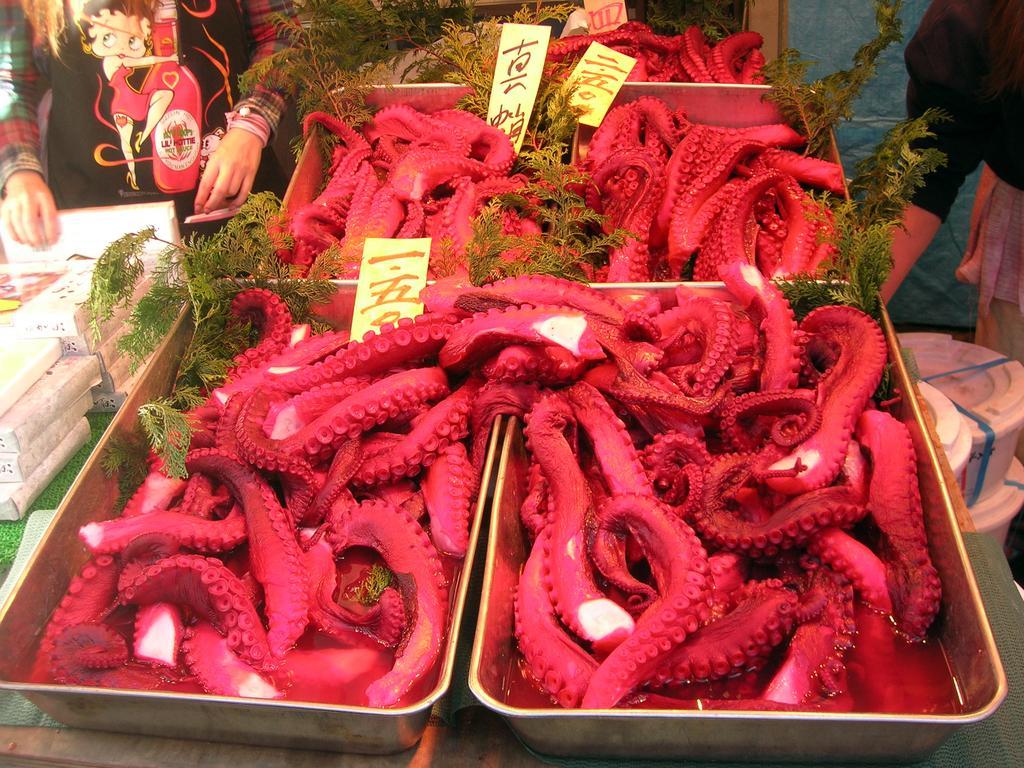Could you give a brief overview of what you see in this image? In the image there are octopuses and on the left there are some objects, in the background there are two people. 